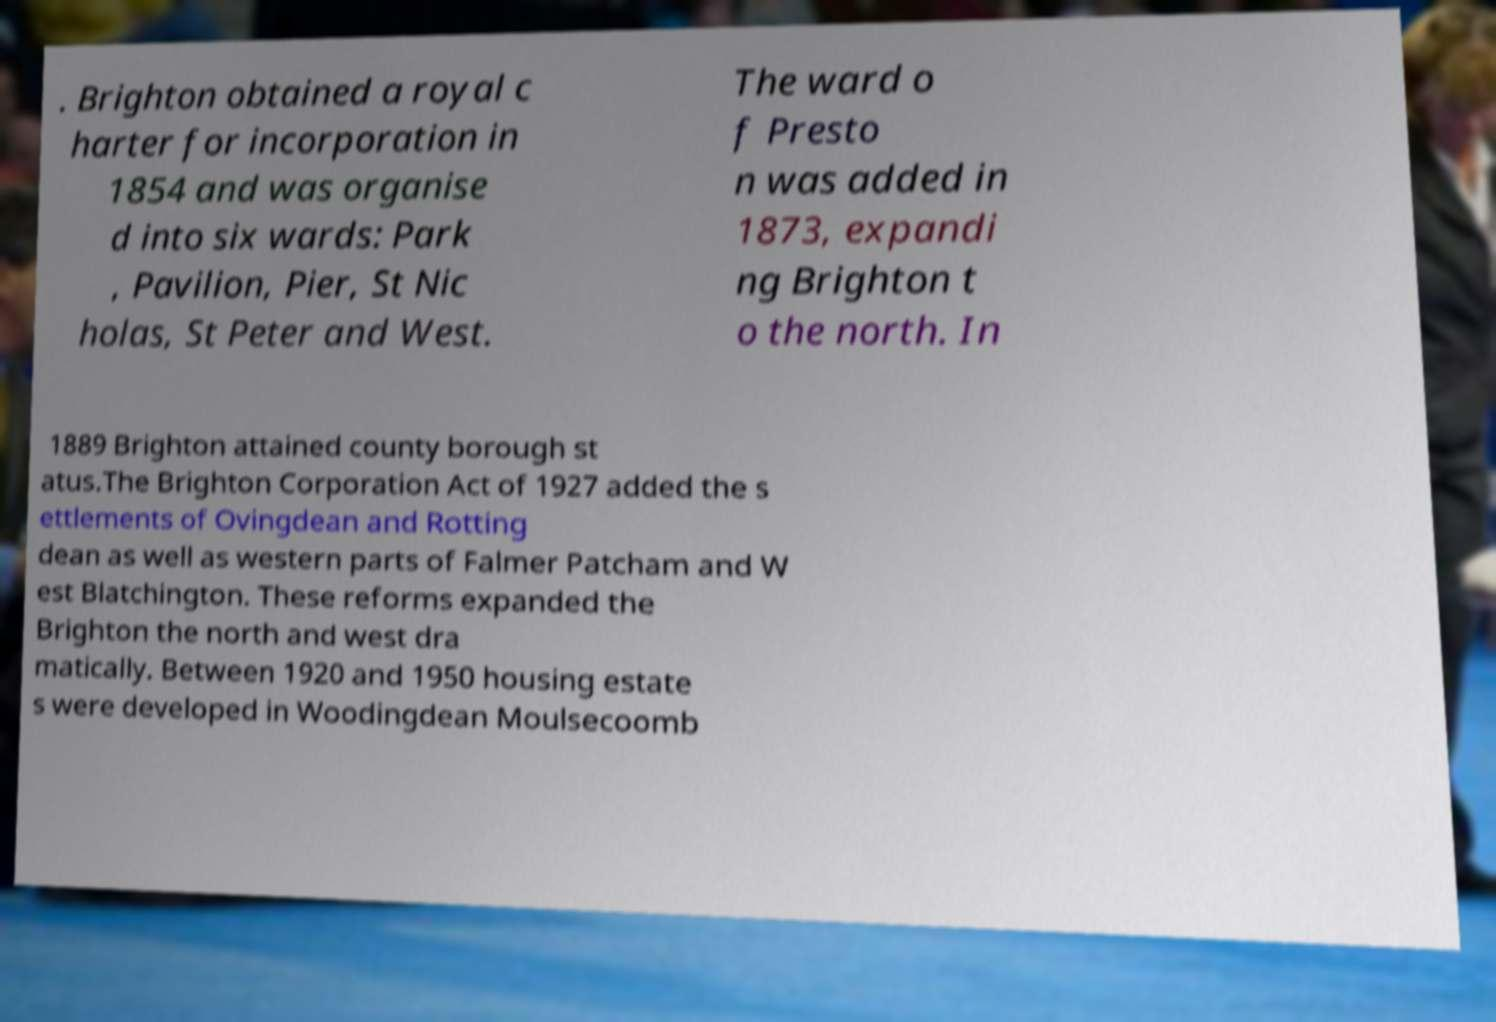There's text embedded in this image that I need extracted. Can you transcribe it verbatim? . Brighton obtained a royal c harter for incorporation in 1854 and was organise d into six wards: Park , Pavilion, Pier, St Nic holas, St Peter and West. The ward o f Presto n was added in 1873, expandi ng Brighton t o the north. In 1889 Brighton attained county borough st atus.The Brighton Corporation Act of 1927 added the s ettlements of Ovingdean and Rotting dean as well as western parts of Falmer Patcham and W est Blatchington. These reforms expanded the Brighton the north and west dra matically. Between 1920 and 1950 housing estate s were developed in Woodingdean Moulsecoomb 